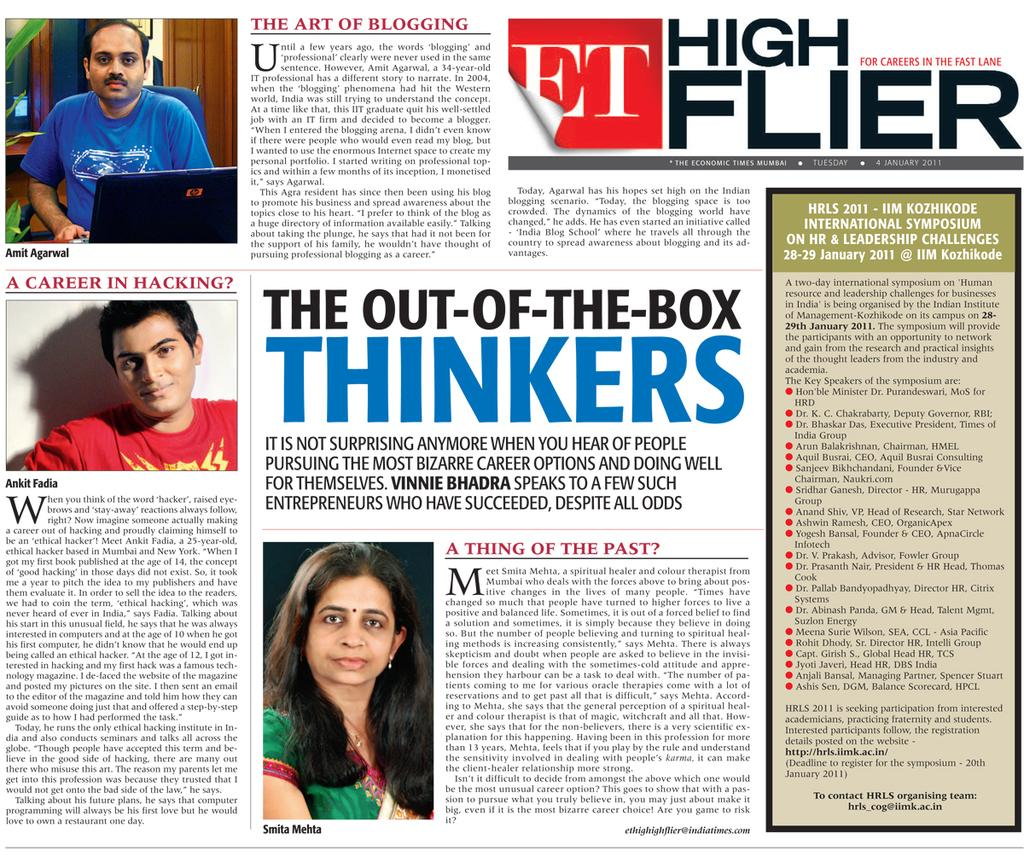What type of visual is the image in question? The image is a poster. What can be seen on the poster? There are images of people on the poster, along with text. Can you describe the scene depicted in the poster? In the left top corner of the poster, there is a person sitting on a chair, chair, and there is a laptop present. What is the purpose of the text on the poster? The text on the poster provides additional information or context about the images of people. What type of crate is being used to store lunch in the image? There is no crate or lunch present in the image; it is a poster featuring images of people and text. 